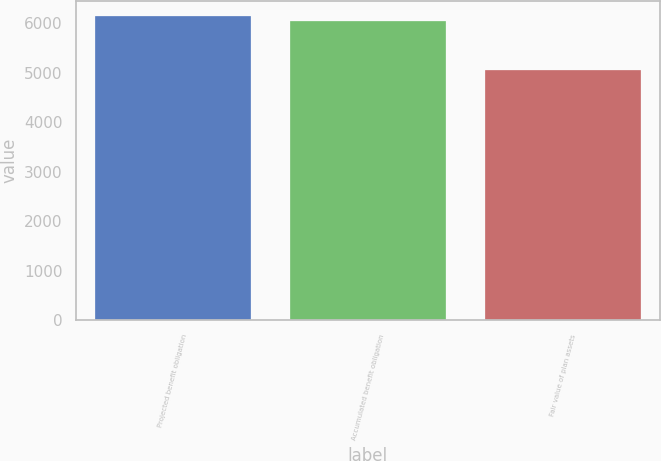<chart> <loc_0><loc_0><loc_500><loc_500><bar_chart><fcel>Projected benefit obligation<fcel>Accumulated benefit obligation<fcel>Fair value of plan assets<nl><fcel>6149.8<fcel>6049<fcel>5063<nl></chart> 